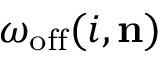Convert formula to latex. <formula><loc_0><loc_0><loc_500><loc_500>\omega _ { o f f } ( i , n )</formula> 